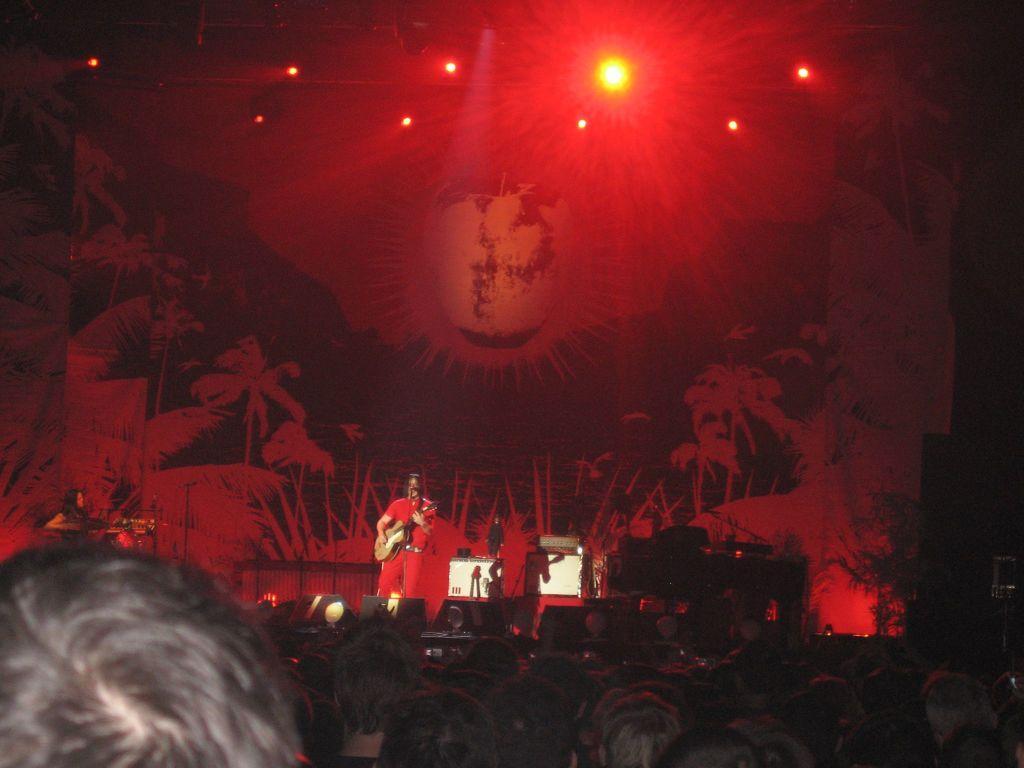Please provide a concise description of this image. In this image we can see the people in front of the stage. And we can see the persons standing on the stage and playing musical instruments. We can see there are lights on the stage. At the top we can see the wall with painting and lights. 